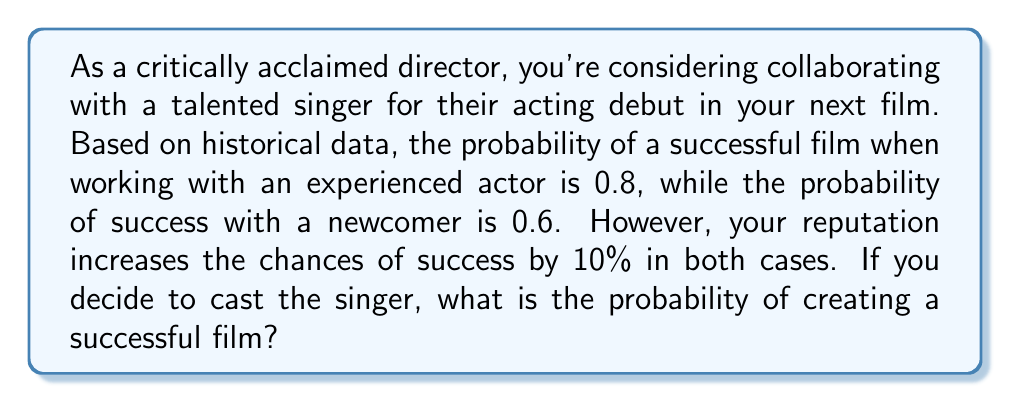Could you help me with this problem? Let's approach this problem step-by-step:

1) First, we need to identify the base probability of success with a newcomer:
   $P(\text{success with newcomer}) = 0.6$

2) Now, we need to account for the director's reputation boost:
   The reputation increases the chances by 10%, which is equivalent to multiplying by 1.1

3) We can calculate the adjusted probability as follows:
   $$P(\text{success}) = P(\text{success with newcomer}) \times (1 + \text{reputation boost})$$
   $$P(\text{success}) = 0.6 \times 1.1$$

4) Let's compute this:
   $$P(\text{success}) = 0.6 \times 1.1 = 0.66$$

Therefore, the probability of creating a successful film with the singer as a newcomer actor, considering the director's reputation boost, is 0.66 or 66%.
Answer: 0.66 or 66% 